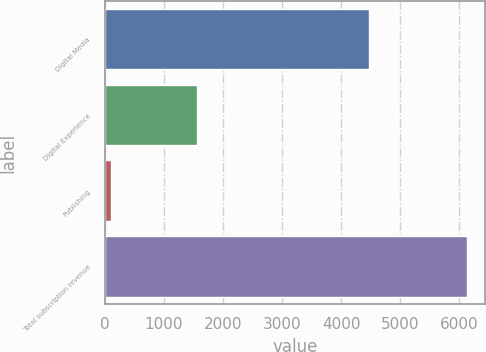Convert chart to OTSL. <chart><loc_0><loc_0><loc_500><loc_500><bar_chart><fcel>Digital Media<fcel>Digital Experience<fcel>Publishing<fcel>Total subscription revenue<nl><fcel>4480.8<fcel>1552.5<fcel>100.6<fcel>6133.9<nl></chart> 